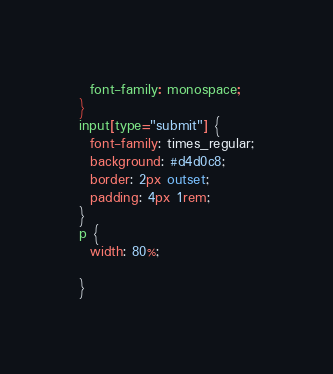<code> <loc_0><loc_0><loc_500><loc_500><_CSS_>  font-family: monospace;
}
input[type="submit"] {
  font-family: times_regular;
  background: #d4d0c8;
  border: 2px outset;
  padding: 4px 1rem;
} 
p {
  width: 80%;

}
</code> 